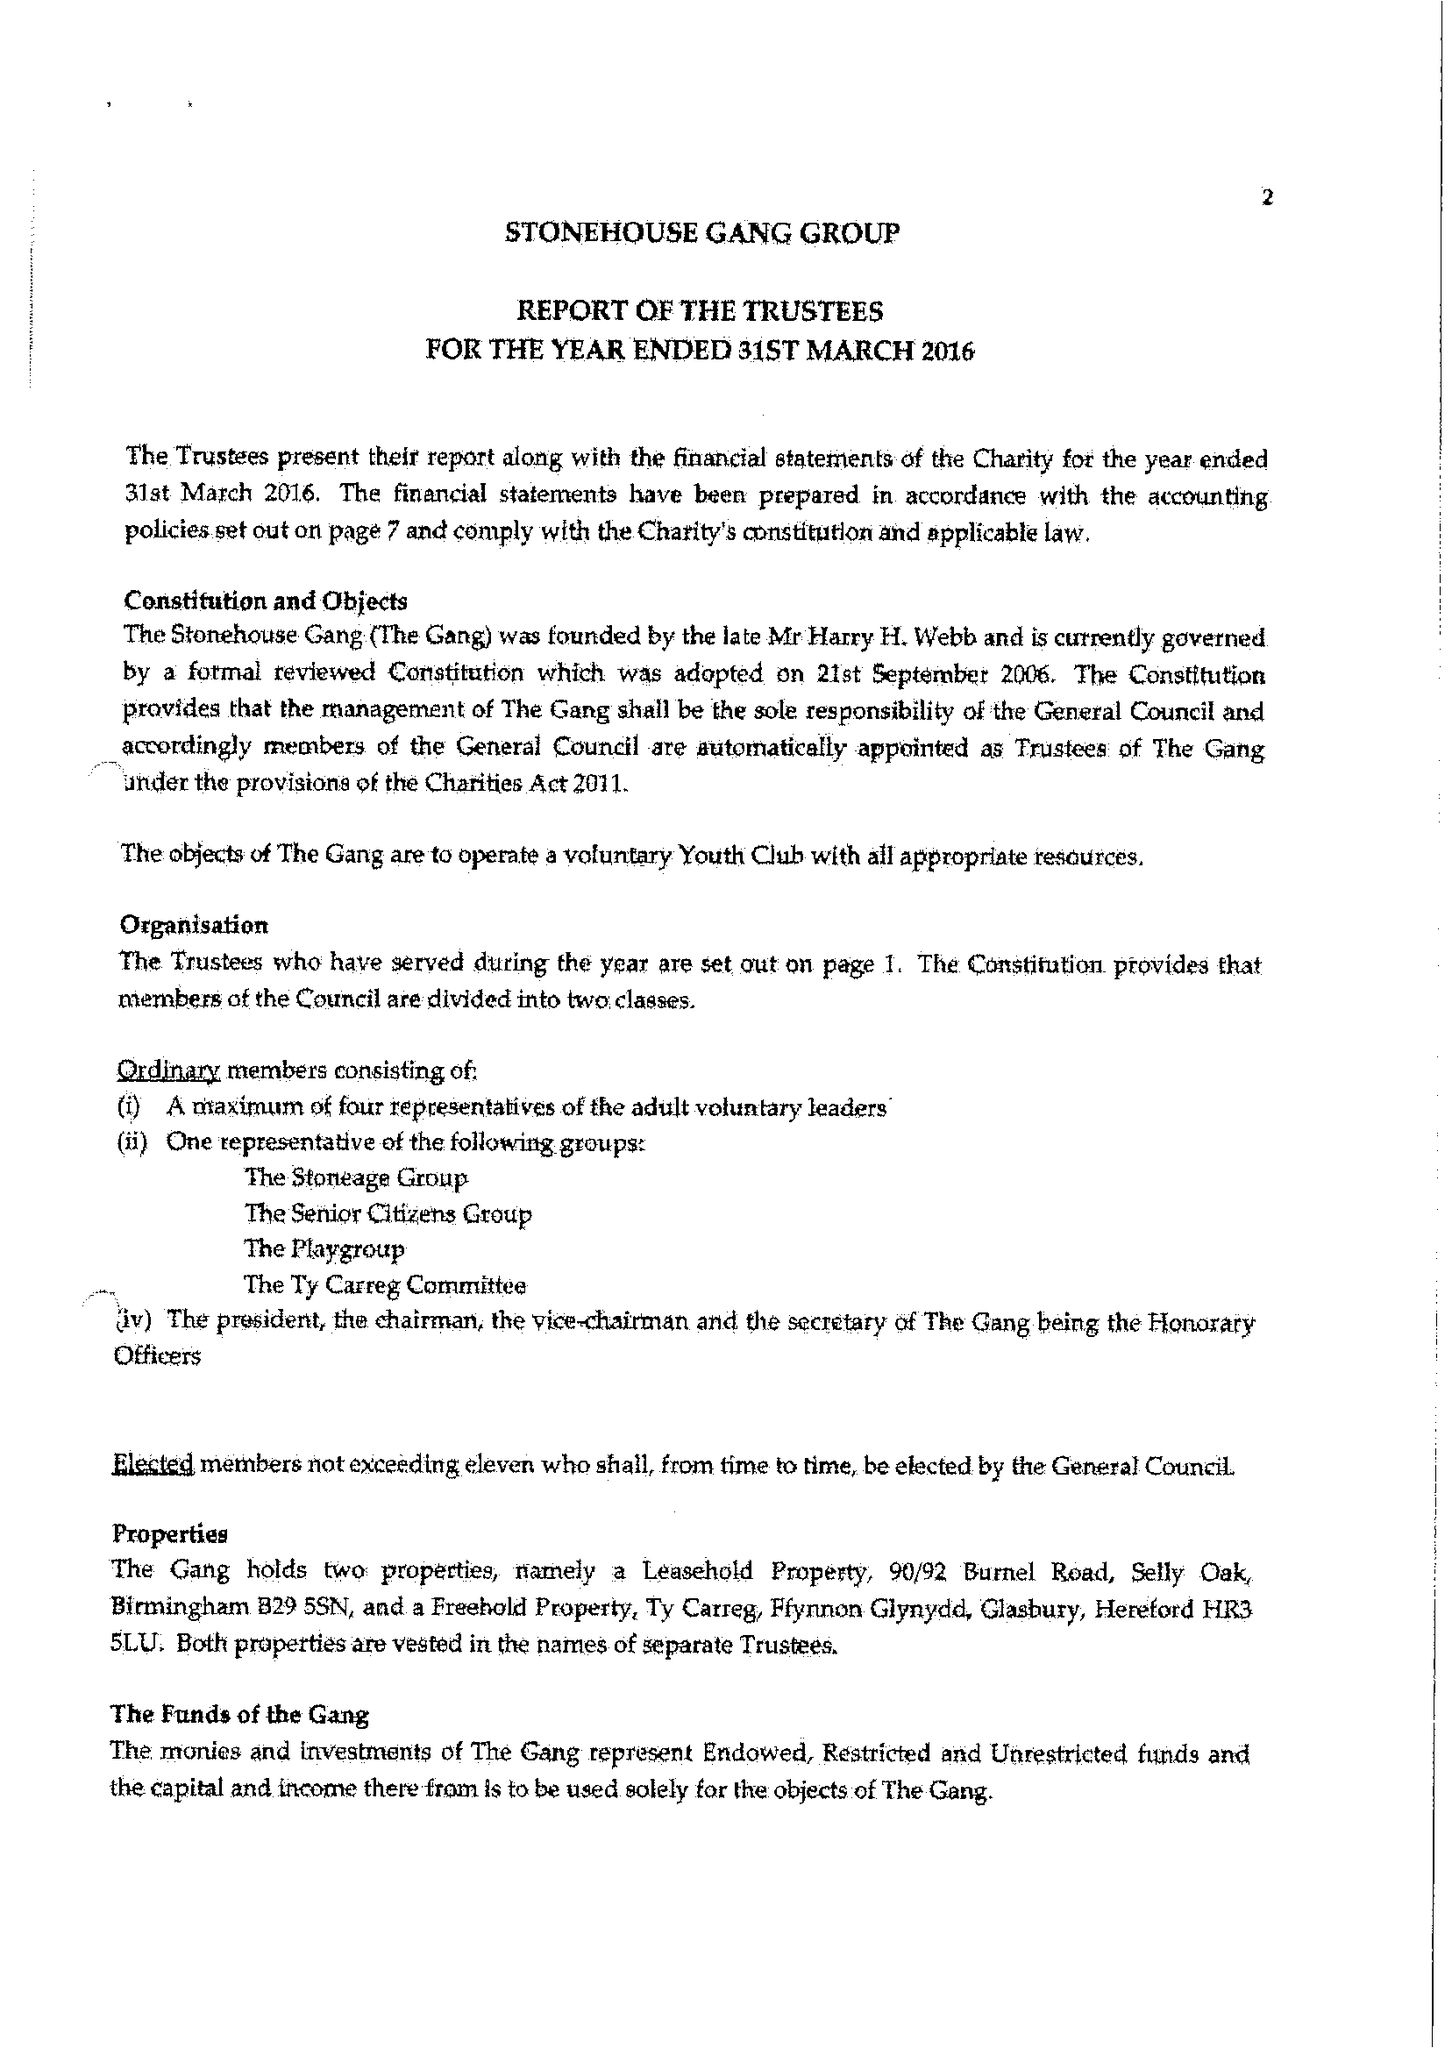What is the value for the report_date?
Answer the question using a single word or phrase. 2015-03-31 